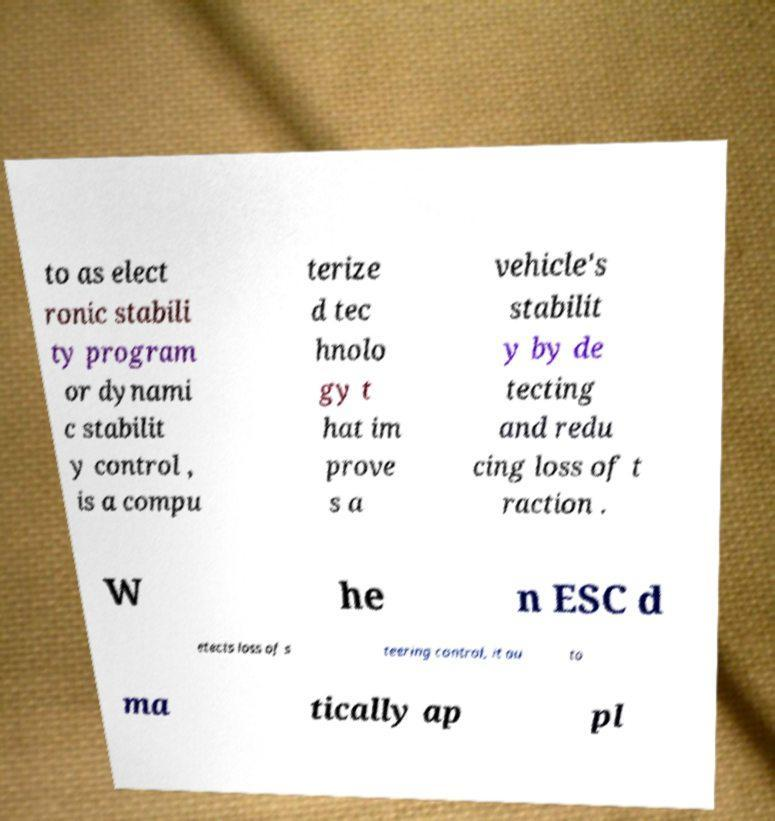There's text embedded in this image that I need extracted. Can you transcribe it verbatim? to as elect ronic stabili ty program or dynami c stabilit y control , is a compu terize d tec hnolo gy t hat im prove s a vehicle's stabilit y by de tecting and redu cing loss of t raction . W he n ESC d etects loss of s teering control, it au to ma tically ap pl 